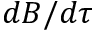<formula> <loc_0><loc_0><loc_500><loc_500>d B / d \tau</formula> 